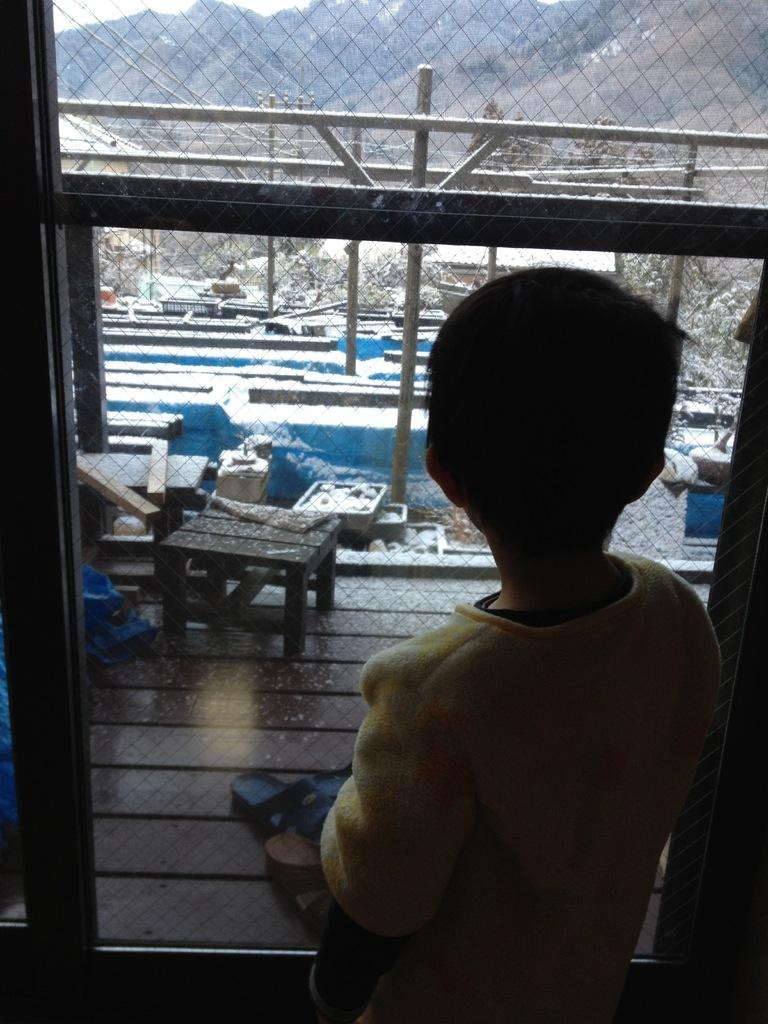What type of structure can be seen in the image? There is a fence in the image. What piece of furniture is present in the image? There is a table in the image. Who is in the image? There is a boy standing in the image. What is the boy wearing? The boy is wearing a yellow shirt. What can be seen in front of the boy? There are chappals in front of the boy. What type of hospital is visible in the image? There is no hospital present in the image. Can you see a bear sitting on the table in the image? There is no bear present in the image. 